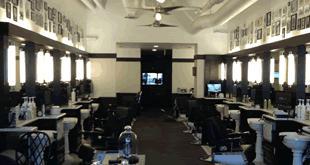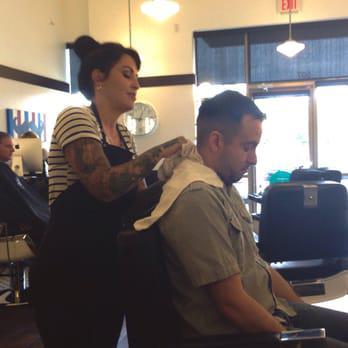The first image is the image on the left, the second image is the image on the right. Considering the images on both sides, is "In one of the images a male customer is being styled by a woman stylist." valid? Answer yes or no. Yes. The first image is the image on the left, the second image is the image on the right. For the images shown, is this caption "One person is sitting in a barbers chair." true? Answer yes or no. Yes. 